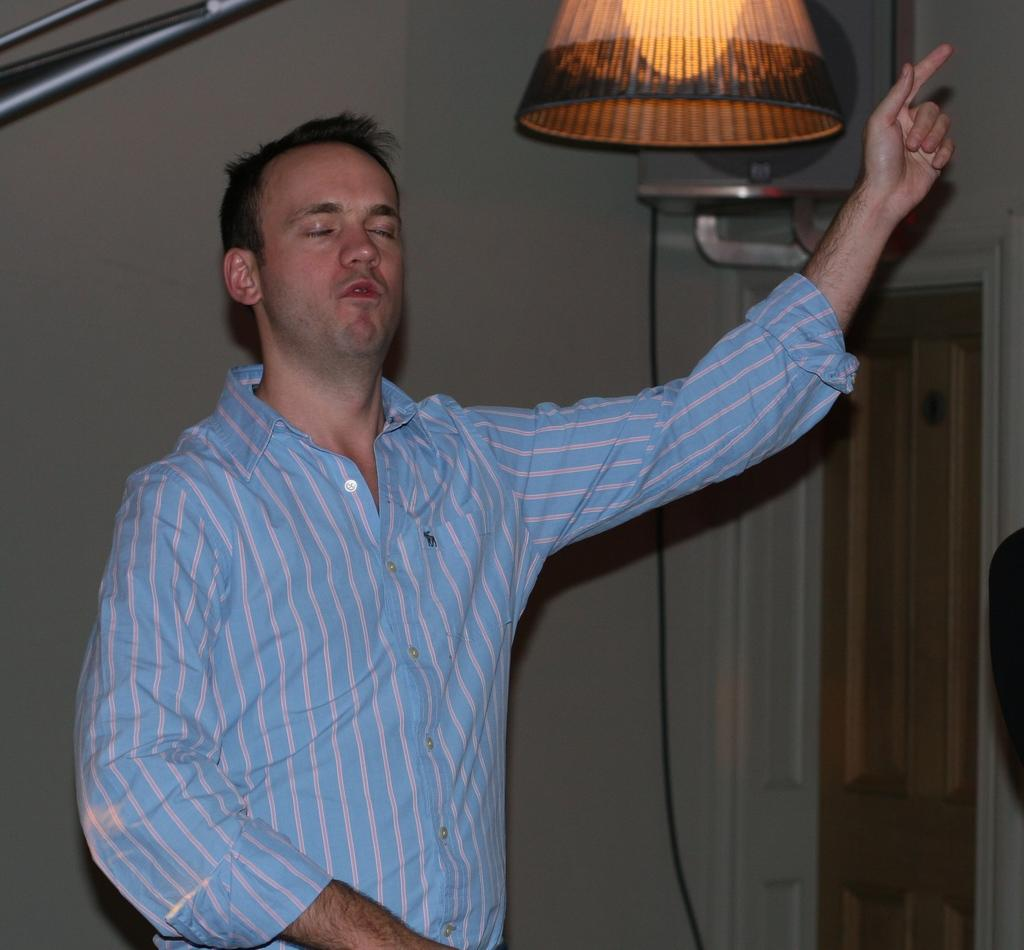What is the man in the center of the picture wearing? The man in the center of the picture is wearing a blue shirt. What can be seen at the top of the image? There is a lamp at the top of the image. What is located behind the man? There is a well behind the man. What is on the right side of the image? There is a door and a cable visible on the right side of the image, as well as another object. What type of plastic is the man playing with in the image? There is no plastic or indication of play in the image; the man is simply standing in the center wearing a blue shirt. 